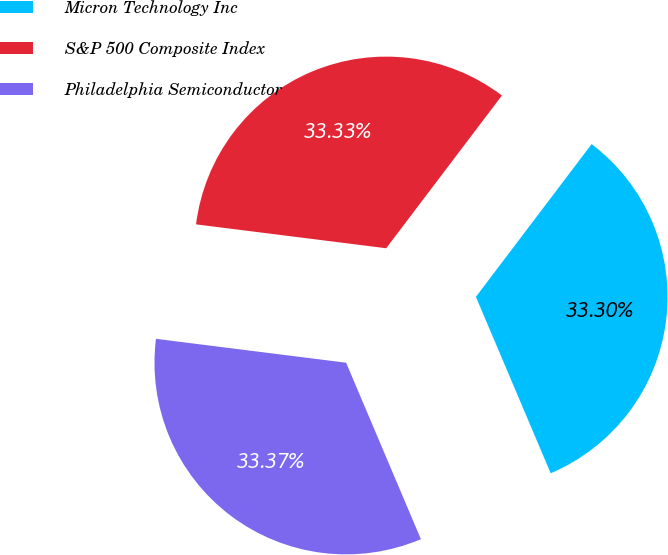Convert chart to OTSL. <chart><loc_0><loc_0><loc_500><loc_500><pie_chart><fcel>Micron Technology Inc<fcel>S&P 500 Composite Index<fcel>Philadelphia Semiconductor<nl><fcel>33.3%<fcel>33.33%<fcel>33.37%<nl></chart> 